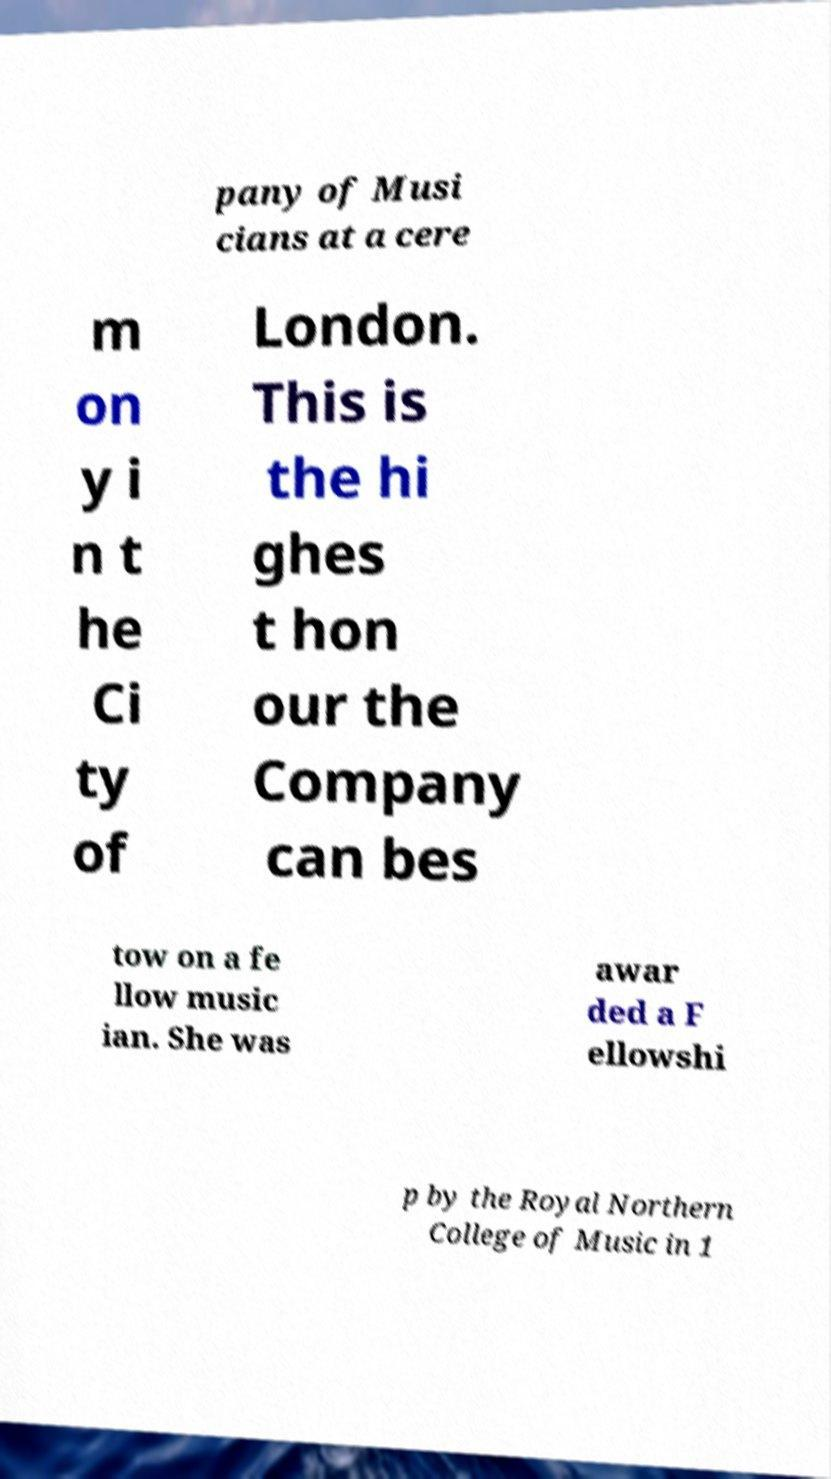I need the written content from this picture converted into text. Can you do that? pany of Musi cians at a cere m on y i n t he Ci ty of London. This is the hi ghes t hon our the Company can bes tow on a fe llow music ian. She was awar ded a F ellowshi p by the Royal Northern College of Music in 1 